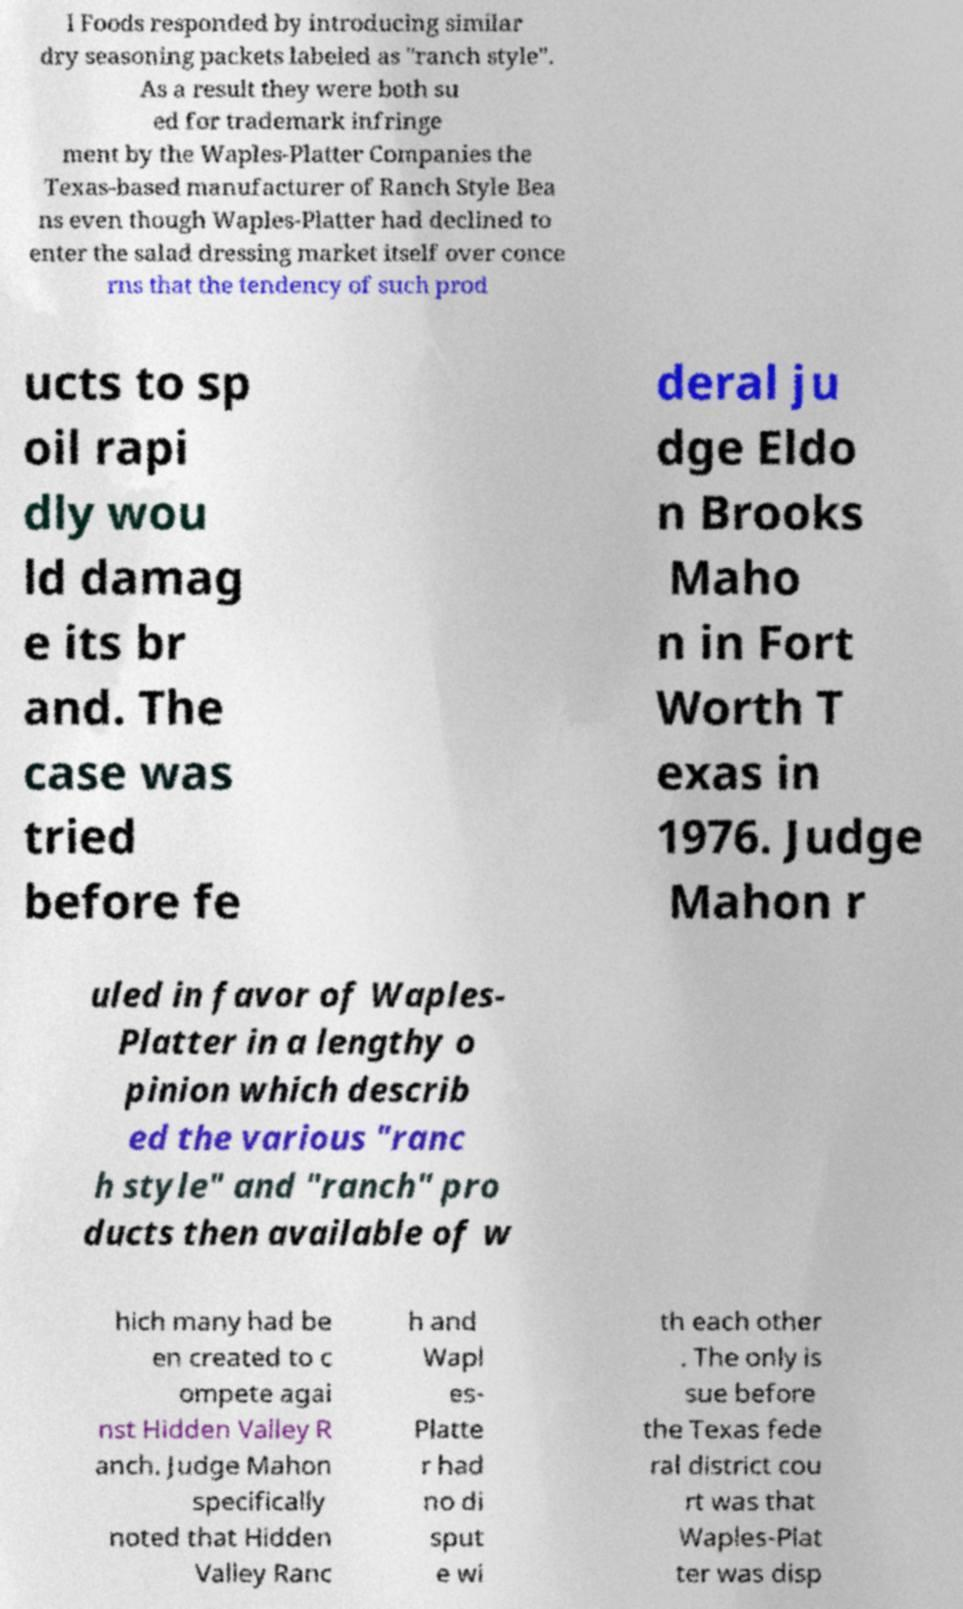Can you read and provide the text displayed in the image?This photo seems to have some interesting text. Can you extract and type it out for me? l Foods responded by introducing similar dry seasoning packets labeled as "ranch style". As a result they were both su ed for trademark infringe ment by the Waples-Platter Companies the Texas-based manufacturer of Ranch Style Bea ns even though Waples-Platter had declined to enter the salad dressing market itself over conce rns that the tendency of such prod ucts to sp oil rapi dly wou ld damag e its br and. The case was tried before fe deral ju dge Eldo n Brooks Maho n in Fort Worth T exas in 1976. Judge Mahon r uled in favor of Waples- Platter in a lengthy o pinion which describ ed the various "ranc h style" and "ranch" pro ducts then available of w hich many had be en created to c ompete agai nst Hidden Valley R anch. Judge Mahon specifically noted that Hidden Valley Ranc h and Wapl es- Platte r had no di sput e wi th each other . The only is sue before the Texas fede ral district cou rt was that Waples-Plat ter was disp 